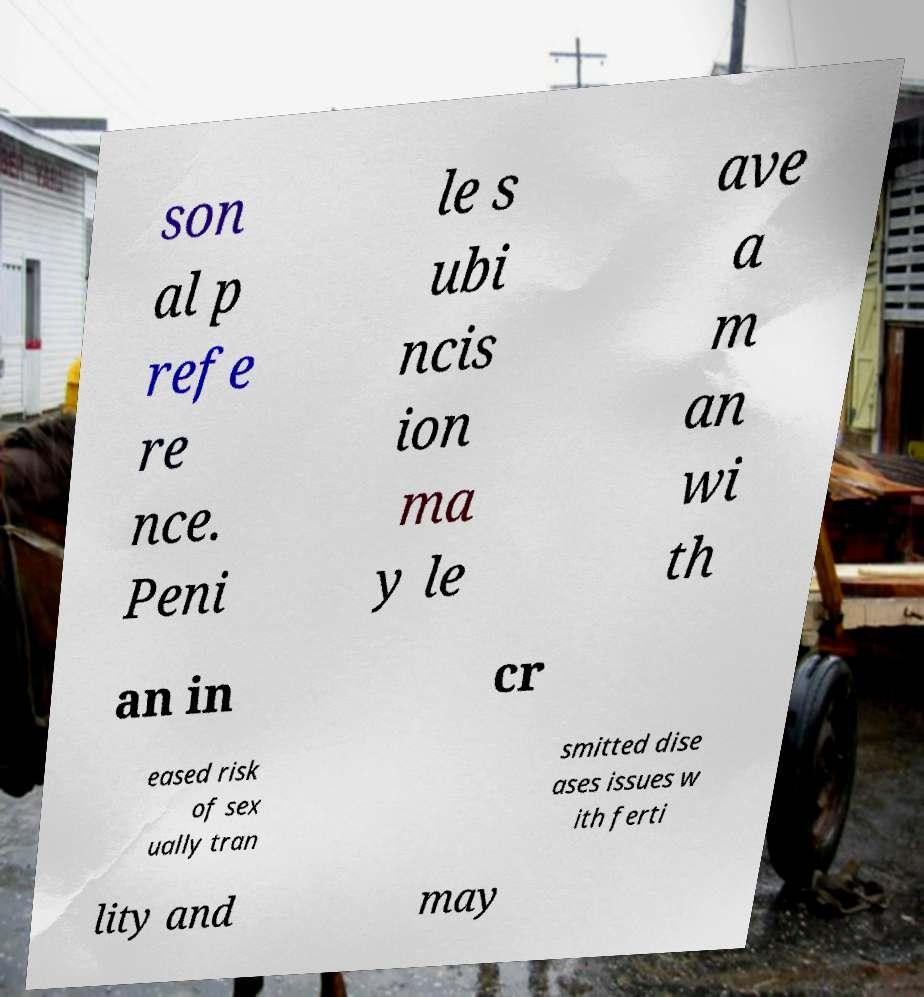Could you extract and type out the text from this image? son al p refe re nce. Peni le s ubi ncis ion ma y le ave a m an wi th an in cr eased risk of sex ually tran smitted dise ases issues w ith ferti lity and may 